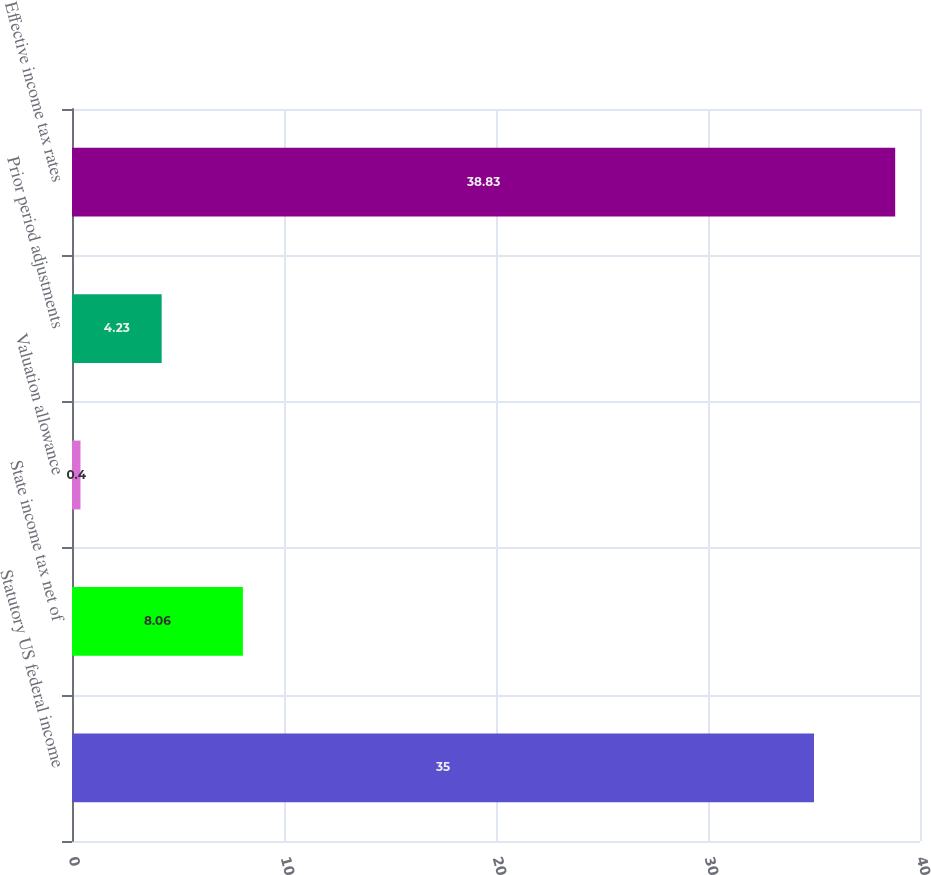<chart> <loc_0><loc_0><loc_500><loc_500><bar_chart><fcel>Statutory US federal income<fcel>State income tax net of<fcel>Valuation allowance<fcel>Prior period adjustments<fcel>Effective income tax rates<nl><fcel>35<fcel>8.06<fcel>0.4<fcel>4.23<fcel>38.83<nl></chart> 